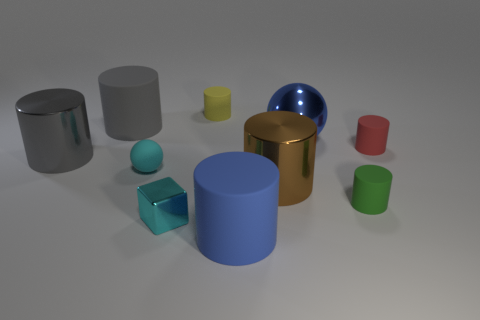There is a large matte thing that is behind the matte cylinder that is in front of the small green rubber cylinder; what is its shape?
Offer a very short reply. Cylinder. How many cylinders are left of the small cylinder that is in front of the large shiny cylinder to the left of the small shiny thing?
Provide a short and direct response. 5. Does the cyan shiny object have the same shape as the blue object that is behind the tiny cyan rubber thing?
Keep it short and to the point. No. Are there more big gray metal cylinders than tiny gray cylinders?
Provide a succinct answer. Yes. Is the shape of the large blue object to the right of the big brown object the same as  the cyan metal object?
Keep it short and to the point. No. Is the number of small red rubber cylinders in front of the yellow cylinder greater than the number of tiny brown spheres?
Ensure brevity in your answer.  Yes. What color is the small thing that is behind the large blue thing that is behind the cyan shiny thing?
Your response must be concise. Yellow. What number of gray metallic balls are there?
Offer a terse response. 0. What number of big rubber things are to the left of the blue matte cylinder and to the right of the tiny yellow rubber object?
Your answer should be compact. 0. Are there any other things that have the same shape as the cyan metallic object?
Keep it short and to the point. No. 